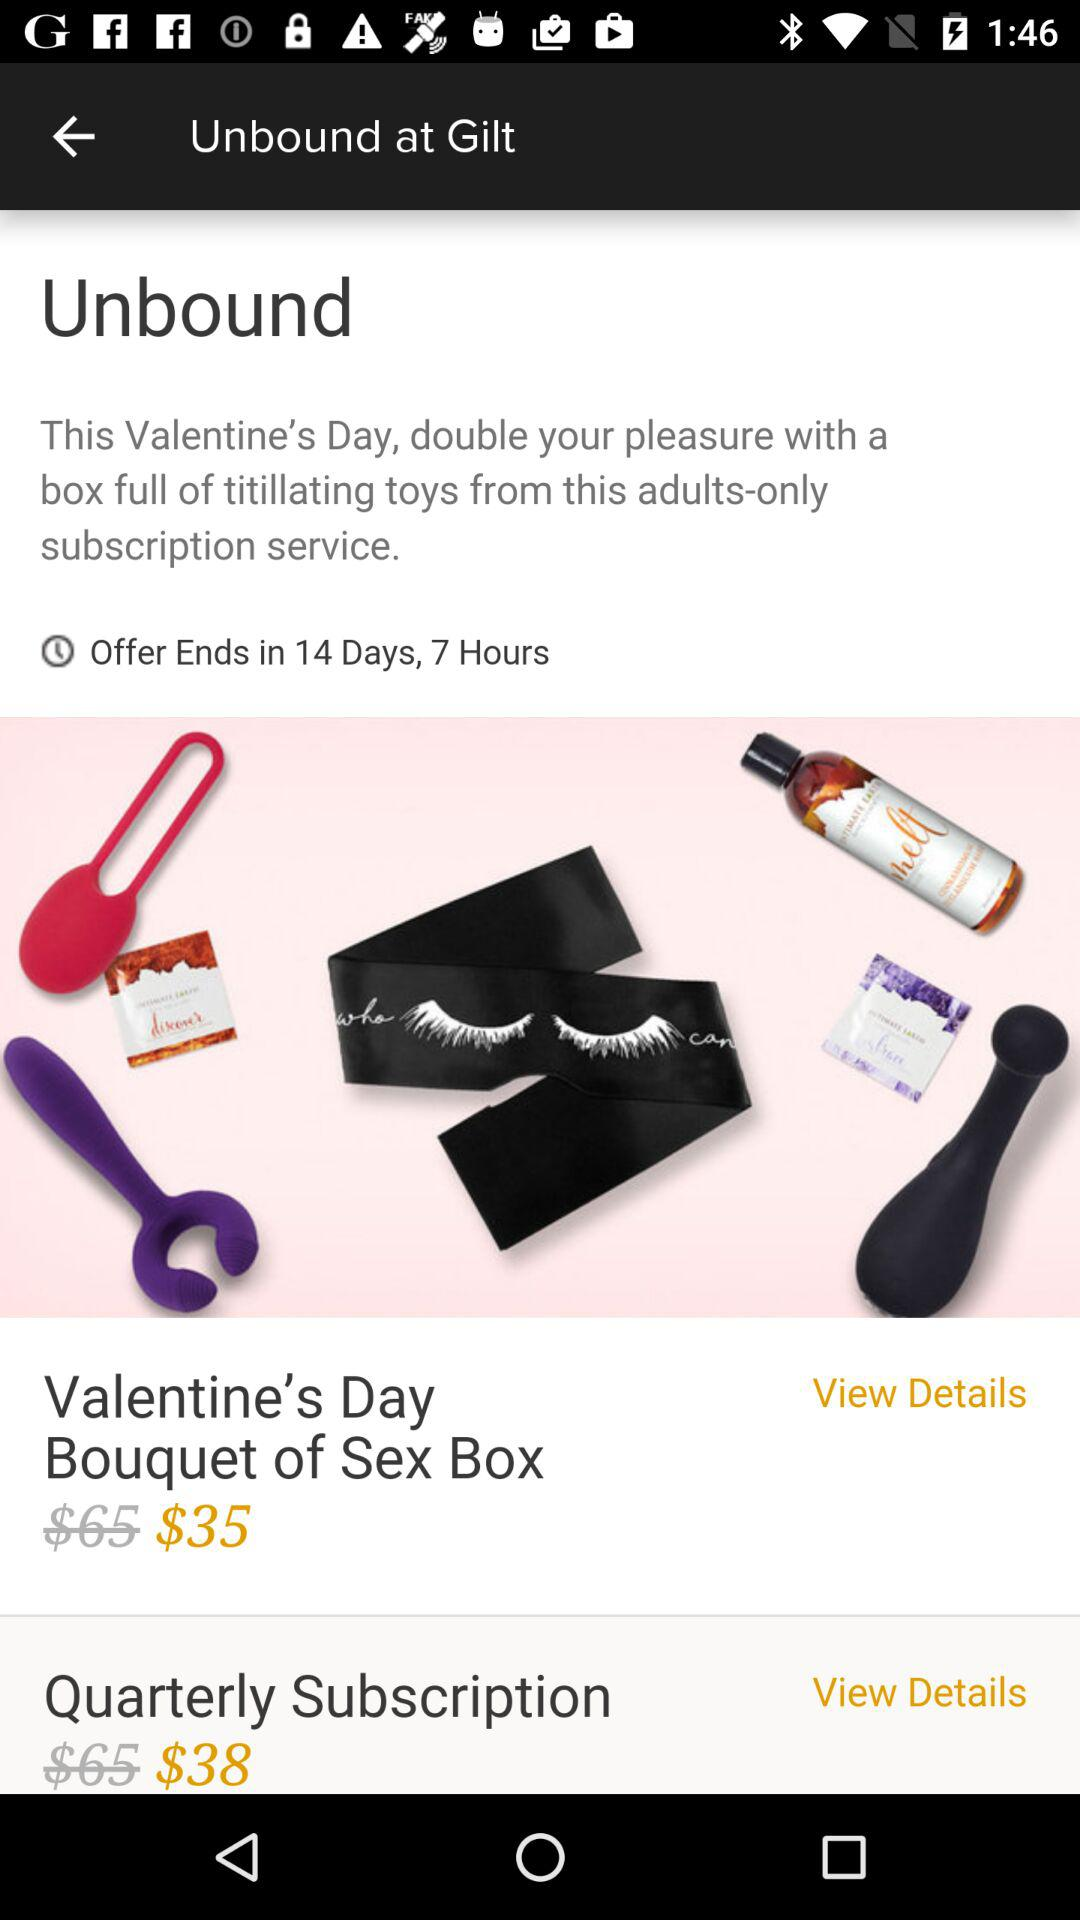How long will the offer be available? The offer will be available for 14 days 7 hours. 